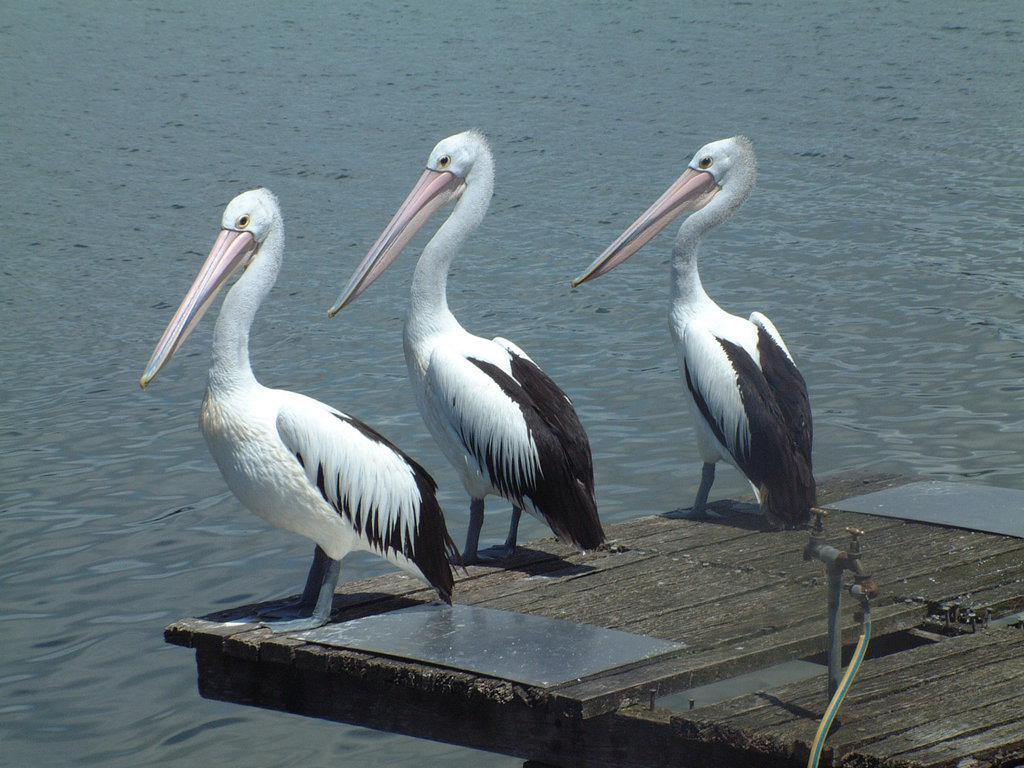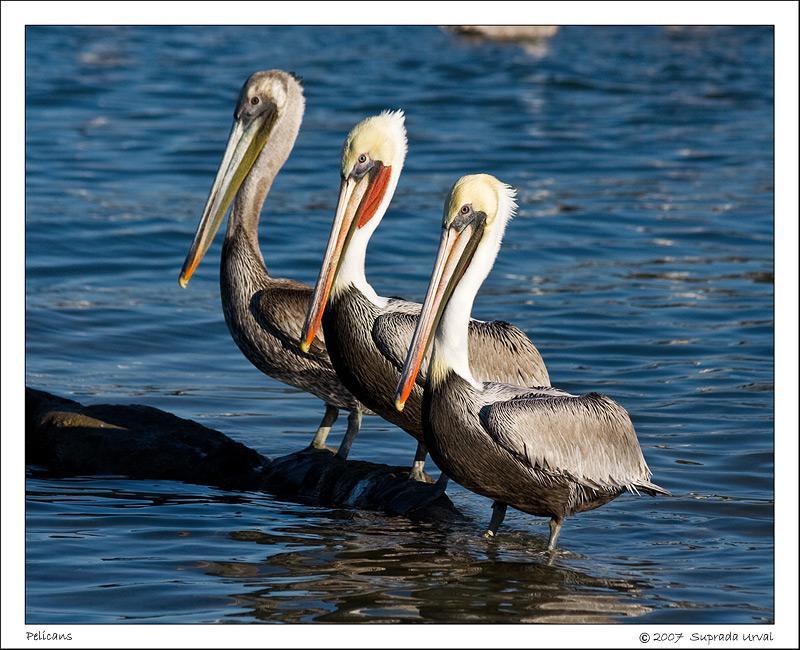The first image is the image on the left, the second image is the image on the right. Evaluate the accuracy of this statement regarding the images: "Three birds are perched on flat planks of a deck.". Is it true? Answer yes or no. Yes. The first image is the image on the left, the second image is the image on the right. Assess this claim about the two images: "Each image contains three left-facing pelicans posed in a row.". Correct or not? Answer yes or no. Yes. 